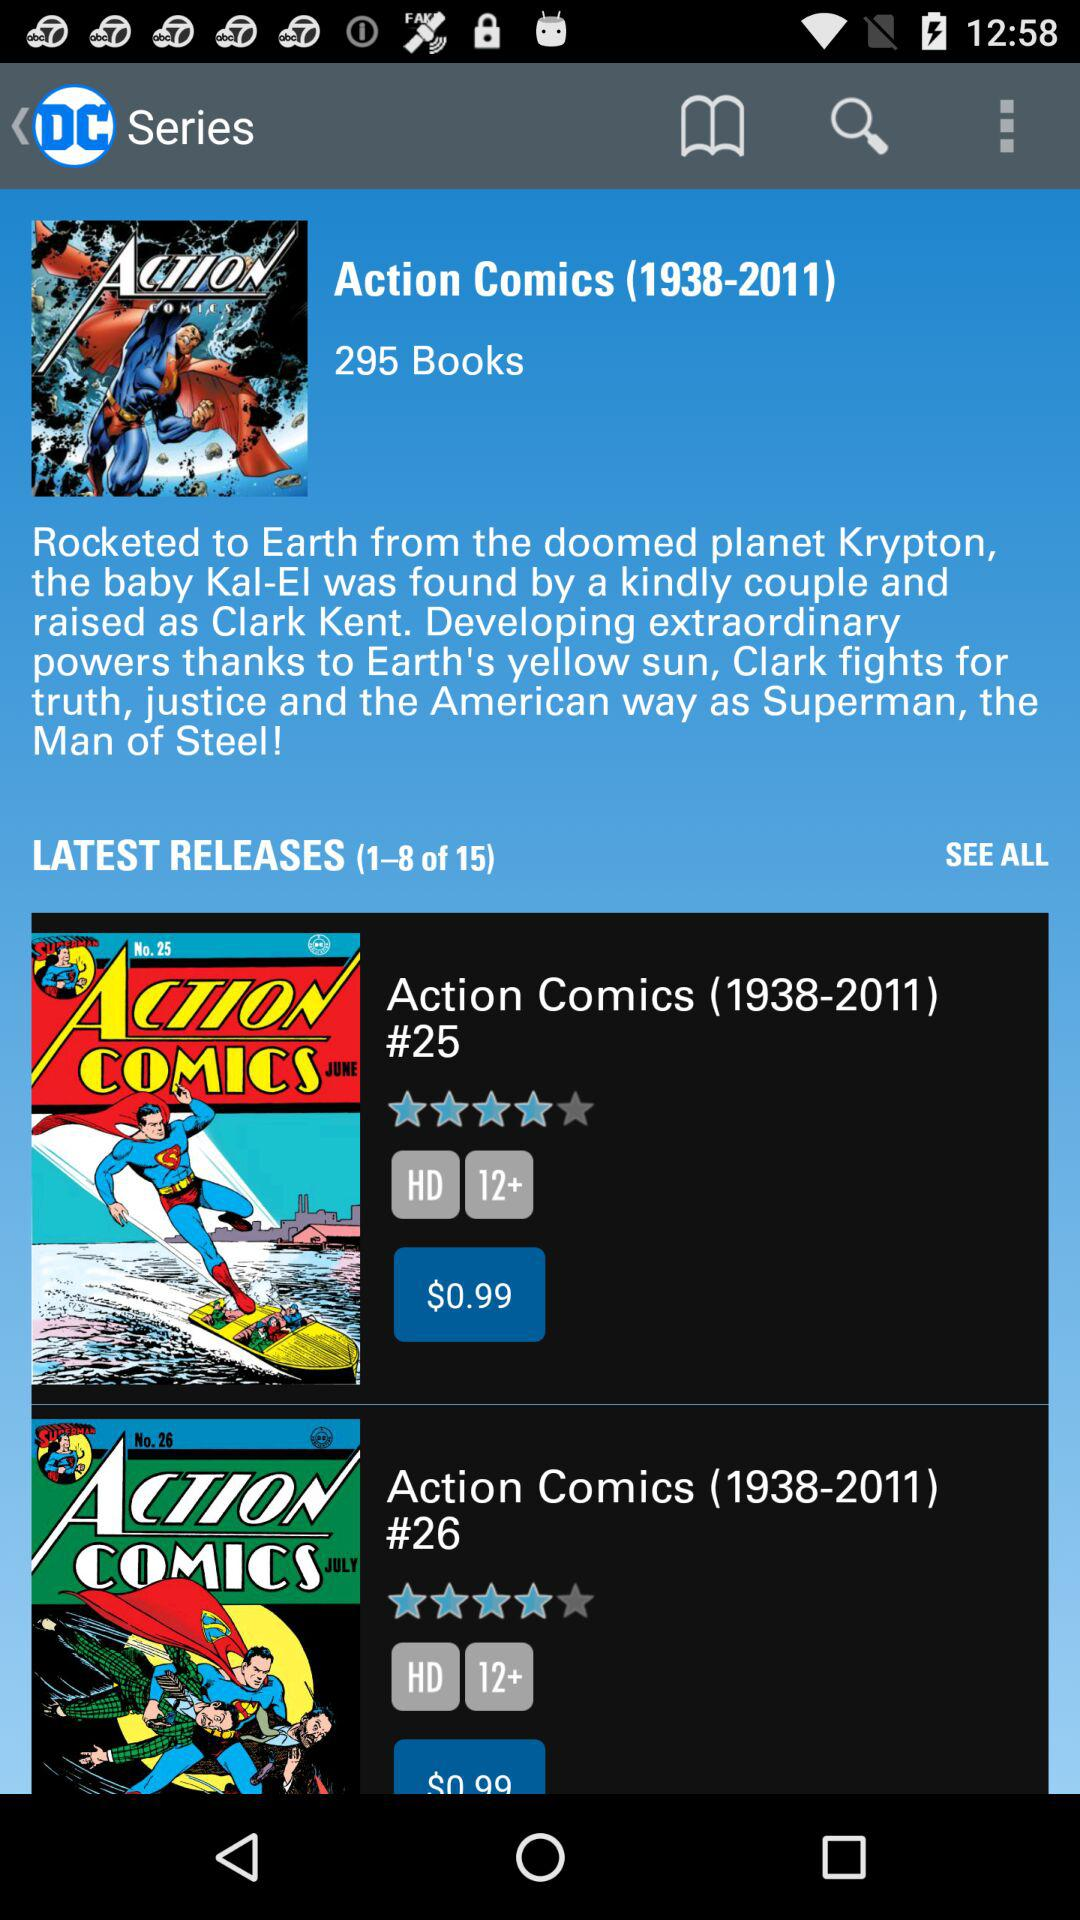Between which years were "Action Comics" books released? "Action Comics" books were released between 1938 and 2011. 